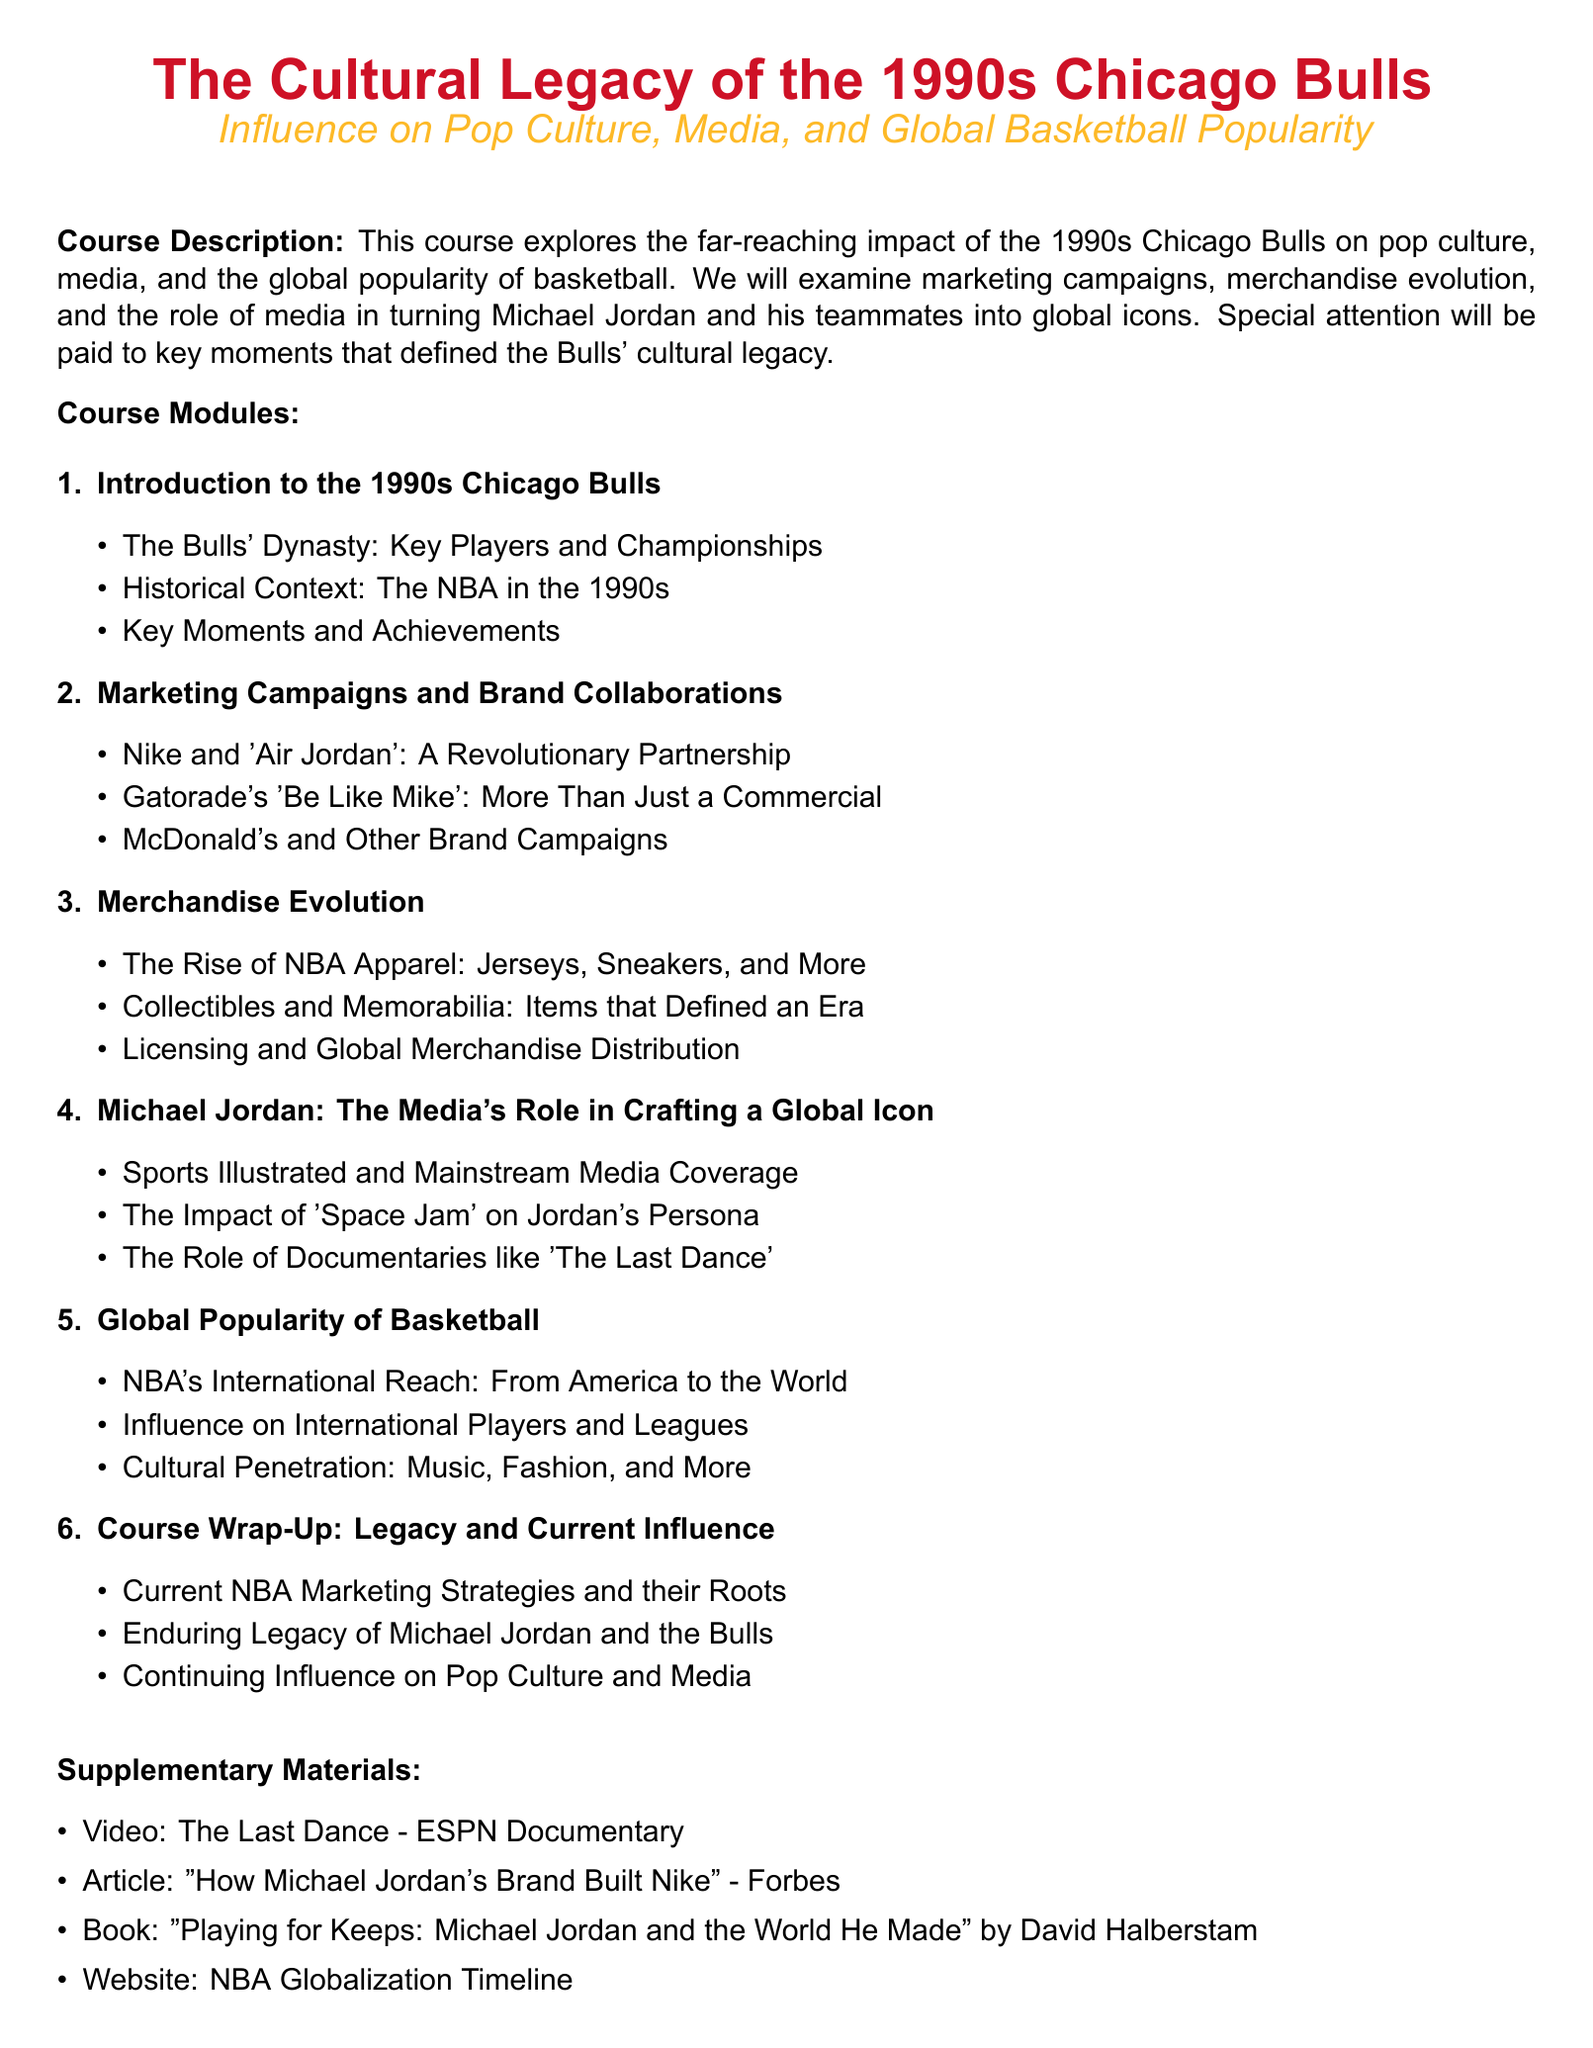What are the key players of the Bulls' dynasty? The key players of the 1990s Chicago Bulls dynasty are mentioned in the course module describing the dynasty and championships.
Answer: Key Players What was Gatorade's campaign slogan associated with the Bulls? The campaign slogan by Gatorade that became synonymous with the Bulls is stated in the marketing section of the syllabus.
Answer: Be Like Mike Which movie helped elevate Michael Jordan’s persona? The impact of this movie on Michael Jordan’s public image is covered in the module about his media representation.
Answer: Space Jam What is the focus of the course module on merchandise evolution? The merchandise evolution module highlights various aspects of NBA apparel and collectibles, reflecting on the era of the Bulls.
Answer: Jerseys, Sneakers, and More What type of supplementary material is included? The document lists various types of materials that support the course content, emphasizing diverse media formats.
Answer: Video, Article, Book, Website What is the final topic addressed in the course wrap-up? The last topic summarizes the enduring impact of the Bulls and their relevance in the current landscape of basketball and media.
Answer: Continuing Influence on Pop Culture and Media How did the Bulls impact international basketball popularity? The course explores how the Bulls influenced the global reach of basketball and its cultural presence.
Answer: NBA's International Reach Which organization is primarily analyzed in terms of marketing strategies in the course? The course reflects on current marketing approaches rooted in the legacy of a significant basketball organization.
Answer: NBA 